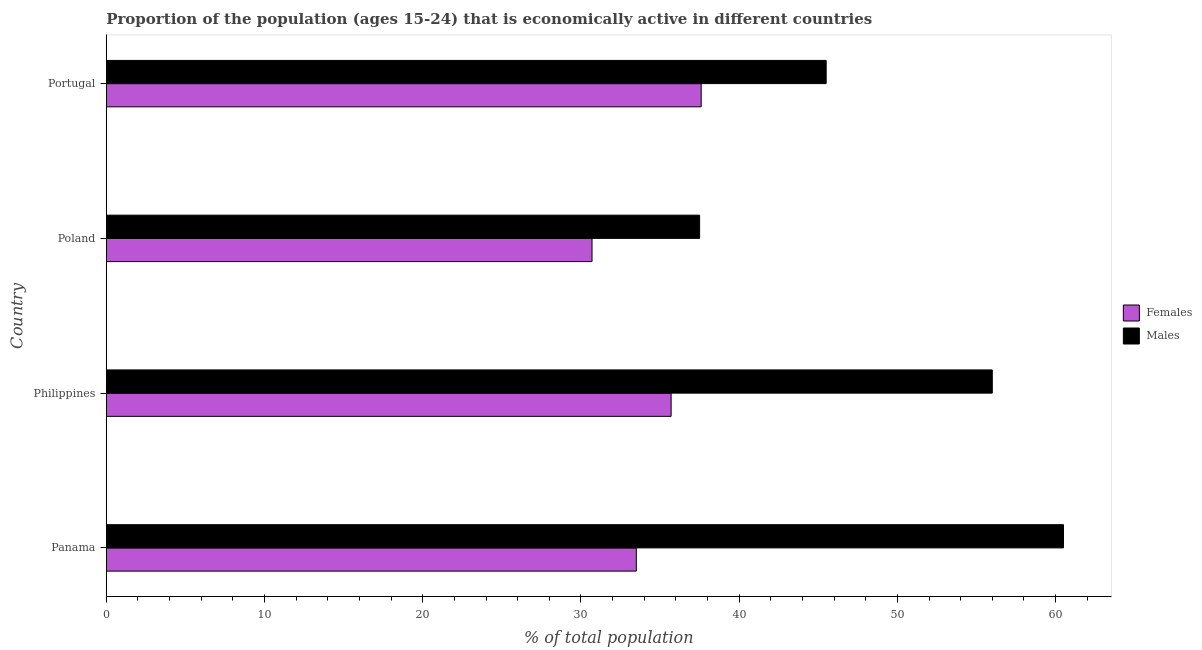Are the number of bars per tick equal to the number of legend labels?
Your answer should be very brief. Yes. How many bars are there on the 2nd tick from the bottom?
Offer a terse response. 2. What is the label of the 4th group of bars from the top?
Your answer should be very brief. Panama. In how many cases, is the number of bars for a given country not equal to the number of legend labels?
Your response must be concise. 0. What is the percentage of economically active male population in Poland?
Your answer should be very brief. 37.5. Across all countries, what is the maximum percentage of economically active female population?
Your response must be concise. 37.6. Across all countries, what is the minimum percentage of economically active female population?
Your answer should be very brief. 30.7. What is the total percentage of economically active female population in the graph?
Provide a succinct answer. 137.5. What is the difference between the percentage of economically active female population in Panama and that in Poland?
Offer a very short reply. 2.8. What is the difference between the percentage of economically active male population in Panama and the percentage of economically active female population in Poland?
Ensure brevity in your answer.  29.8. What is the average percentage of economically active female population per country?
Give a very brief answer. 34.38. In how many countries, is the percentage of economically active male population greater than 30 %?
Keep it short and to the point. 4. What is the ratio of the percentage of economically active female population in Philippines to that in Poland?
Your answer should be compact. 1.16. Is the percentage of economically active male population in Panama less than that in Philippines?
Keep it short and to the point. No. Is the difference between the percentage of economically active female population in Poland and Portugal greater than the difference between the percentage of economically active male population in Poland and Portugal?
Give a very brief answer. Yes. What is the difference between the highest and the second highest percentage of economically active male population?
Your answer should be compact. 4.5. What is the difference between the highest and the lowest percentage of economically active female population?
Offer a terse response. 6.9. What does the 2nd bar from the top in Philippines represents?
Give a very brief answer. Females. What does the 1st bar from the bottom in Philippines represents?
Give a very brief answer. Females. Are all the bars in the graph horizontal?
Provide a short and direct response. Yes. Does the graph contain any zero values?
Offer a very short reply. No. How many legend labels are there?
Keep it short and to the point. 2. What is the title of the graph?
Your answer should be compact. Proportion of the population (ages 15-24) that is economically active in different countries. Does "IMF concessional" appear as one of the legend labels in the graph?
Keep it short and to the point. No. What is the label or title of the X-axis?
Provide a succinct answer. % of total population. What is the label or title of the Y-axis?
Offer a very short reply. Country. What is the % of total population of Females in Panama?
Ensure brevity in your answer.  33.5. What is the % of total population of Males in Panama?
Provide a succinct answer. 60.5. What is the % of total population in Females in Philippines?
Your answer should be compact. 35.7. What is the % of total population of Females in Poland?
Provide a succinct answer. 30.7. What is the % of total population of Males in Poland?
Provide a succinct answer. 37.5. What is the % of total population of Females in Portugal?
Provide a succinct answer. 37.6. What is the % of total population in Males in Portugal?
Your answer should be very brief. 45.5. Across all countries, what is the maximum % of total population of Females?
Give a very brief answer. 37.6. Across all countries, what is the maximum % of total population in Males?
Keep it short and to the point. 60.5. Across all countries, what is the minimum % of total population in Females?
Make the answer very short. 30.7. Across all countries, what is the minimum % of total population of Males?
Your response must be concise. 37.5. What is the total % of total population of Females in the graph?
Provide a succinct answer. 137.5. What is the total % of total population of Males in the graph?
Provide a succinct answer. 199.5. What is the difference between the % of total population in Males in Panama and that in Philippines?
Your answer should be compact. 4.5. What is the difference between the % of total population in Females in Panama and that in Poland?
Provide a succinct answer. 2.8. What is the difference between the % of total population of Males in Philippines and that in Poland?
Your answer should be compact. 18.5. What is the difference between the % of total population in Males in Philippines and that in Portugal?
Give a very brief answer. 10.5. What is the difference between the % of total population in Females in Poland and that in Portugal?
Your answer should be compact. -6.9. What is the difference between the % of total population of Females in Panama and the % of total population of Males in Philippines?
Make the answer very short. -22.5. What is the difference between the % of total population of Females in Poland and the % of total population of Males in Portugal?
Make the answer very short. -14.8. What is the average % of total population in Females per country?
Your answer should be compact. 34.38. What is the average % of total population of Males per country?
Provide a succinct answer. 49.88. What is the difference between the % of total population of Females and % of total population of Males in Panama?
Offer a very short reply. -27. What is the difference between the % of total population of Females and % of total population of Males in Philippines?
Provide a short and direct response. -20.3. What is the difference between the % of total population of Females and % of total population of Males in Portugal?
Provide a short and direct response. -7.9. What is the ratio of the % of total population of Females in Panama to that in Philippines?
Offer a terse response. 0.94. What is the ratio of the % of total population of Males in Panama to that in Philippines?
Your answer should be very brief. 1.08. What is the ratio of the % of total population in Females in Panama to that in Poland?
Your answer should be very brief. 1.09. What is the ratio of the % of total population in Males in Panama to that in Poland?
Provide a succinct answer. 1.61. What is the ratio of the % of total population in Females in Panama to that in Portugal?
Provide a short and direct response. 0.89. What is the ratio of the % of total population in Males in Panama to that in Portugal?
Offer a very short reply. 1.33. What is the ratio of the % of total population of Females in Philippines to that in Poland?
Offer a terse response. 1.16. What is the ratio of the % of total population in Males in Philippines to that in Poland?
Your answer should be compact. 1.49. What is the ratio of the % of total population in Females in Philippines to that in Portugal?
Keep it short and to the point. 0.95. What is the ratio of the % of total population of Males in Philippines to that in Portugal?
Provide a succinct answer. 1.23. What is the ratio of the % of total population in Females in Poland to that in Portugal?
Make the answer very short. 0.82. What is the ratio of the % of total population in Males in Poland to that in Portugal?
Your response must be concise. 0.82. What is the difference between the highest and the second highest % of total population of Males?
Make the answer very short. 4.5. What is the difference between the highest and the lowest % of total population in Females?
Your answer should be very brief. 6.9. 